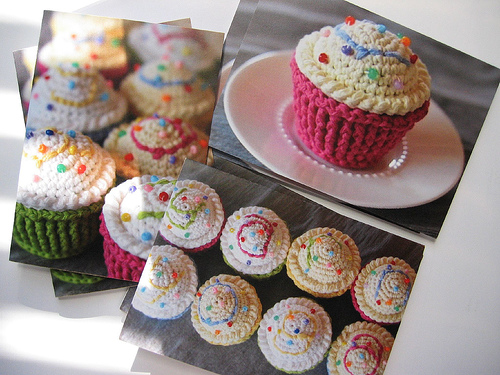<image>
Is there a cake on the plate? Yes. Looking at the image, I can see the cake is positioned on top of the plate, with the plate providing support. 